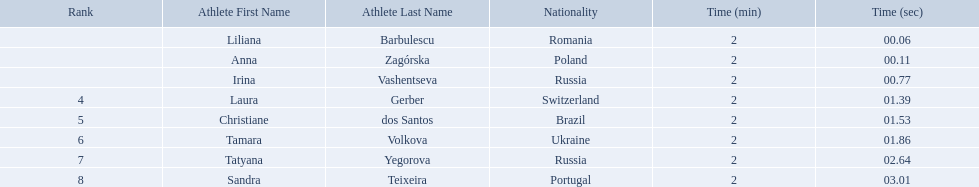Which athletes competed in the 2003 summer universiade - women's 800 metres? Liliana Barbulescu, Anna Zagórska, Irina Vashentseva, Laura Gerber, Christiane dos Santos, Tamara Volkova, Tatyana Yegorova, Sandra Teixeira. Of these, which are from poland? Anna Zagórska. What is her time? 2:00.11. What were all the finishing times? 2:00.06, 2:00.11, 2:00.77, 2:01.39, 2:01.53, 2:01.86, 2:02.64, 2:03.01. Which of these is anna zagorska's? 2:00.11. 